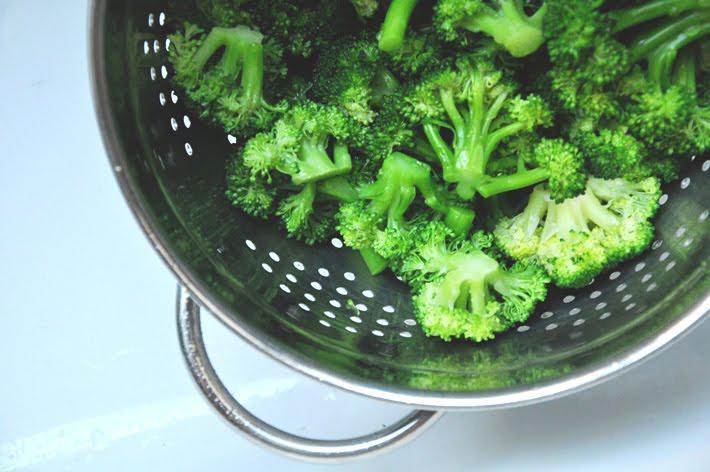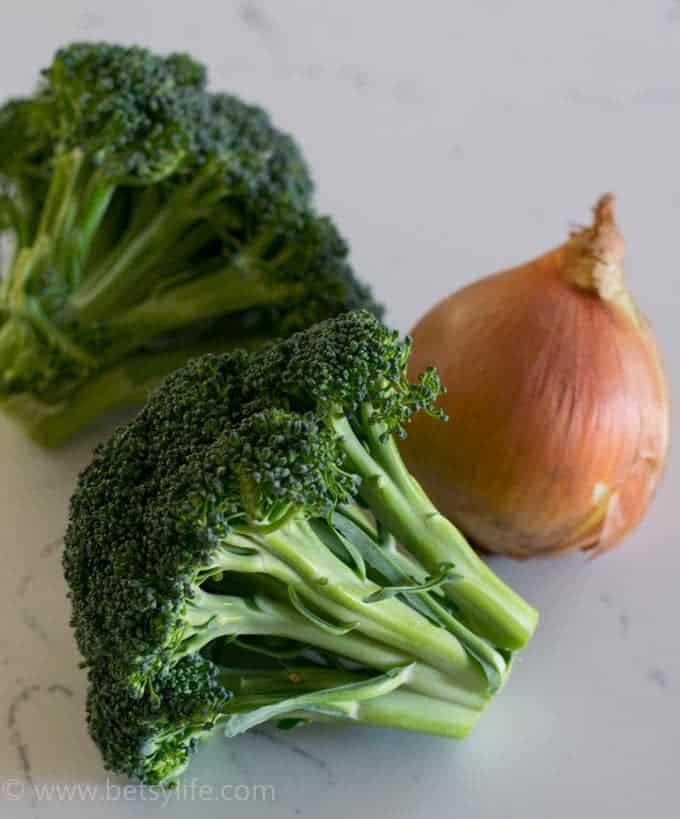The first image is the image on the left, the second image is the image on the right. Examine the images to the left and right. Is the description "One image shows one roundish head of a yellow-green cauliflower type vegetable, and the other image features darker green broccoli florets." accurate? Answer yes or no. No. The first image is the image on the left, the second image is the image on the right. Considering the images on both sides, is "In at least one image there is a single head of green cauliflower." valid? Answer yes or no. No. 